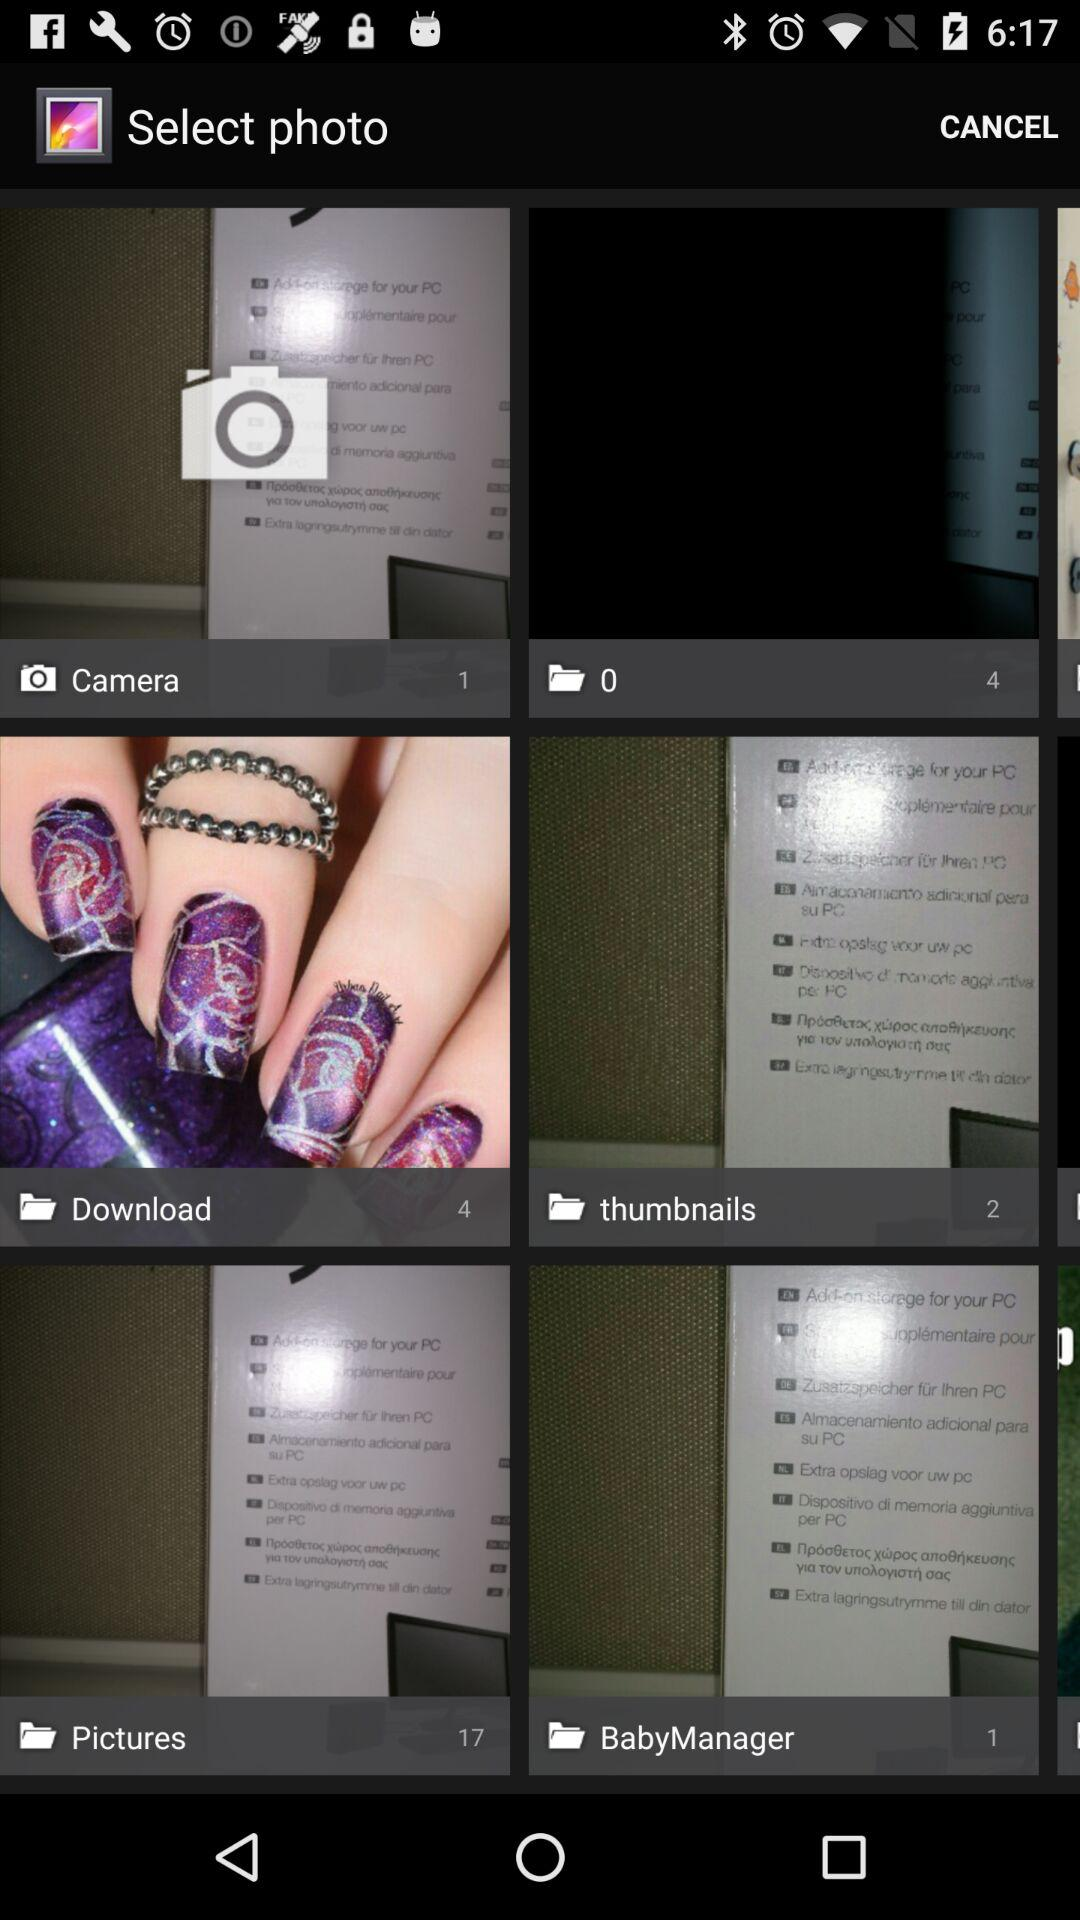What is the count of photos in the "BabyManager" folder? The count of photos is 1. 